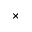Convert formula to latex. <formula><loc_0><loc_0><loc_500><loc_500>\times</formula> 